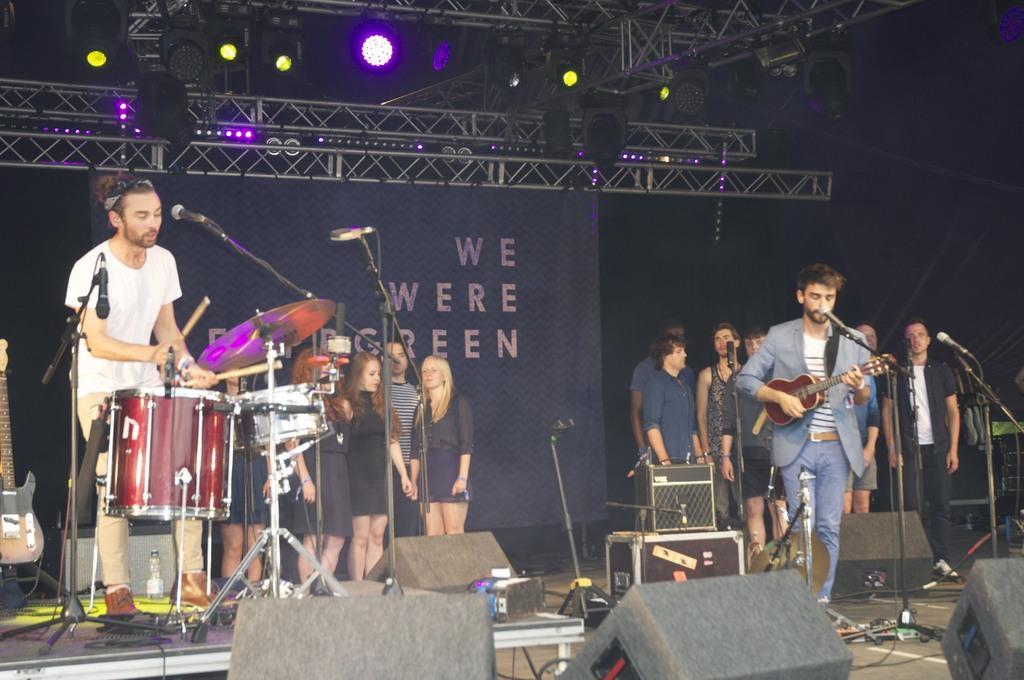In one or two sentences, can you explain what this image depicts? In this image a man standing in the stage and singing a song in the microphone by playing guitar and at the left side of him there is a man who is playing the drums ,cymbals,crash cymbals and a cymbal stand and at the back ground there are group of people who are singing the song and there are another group of people who are singing the song , and speakers and focus lights fixed to the iron rods. 